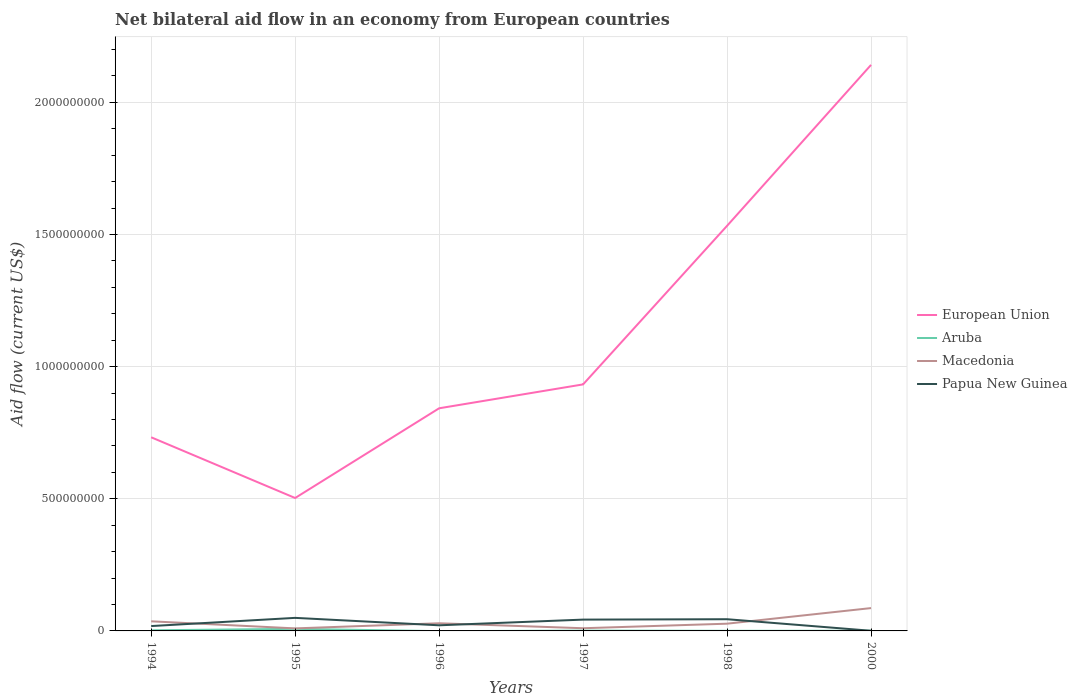How many different coloured lines are there?
Your response must be concise. 4. Does the line corresponding to Aruba intersect with the line corresponding to Papua New Guinea?
Your answer should be compact. Yes. Across all years, what is the maximum net bilateral aid flow in European Union?
Your answer should be compact. 5.03e+08. What is the total net bilateral aid flow in Macedonia in the graph?
Provide a short and direct response. -5.00e+07. What is the difference between the highest and the second highest net bilateral aid flow in Papua New Guinea?
Keep it short and to the point. 4.88e+07. What is the difference between the highest and the lowest net bilateral aid flow in European Union?
Provide a succinct answer. 2. How many lines are there?
Keep it short and to the point. 4. How many years are there in the graph?
Your answer should be compact. 6. What is the difference between two consecutive major ticks on the Y-axis?
Ensure brevity in your answer.  5.00e+08. Are the values on the major ticks of Y-axis written in scientific E-notation?
Your answer should be compact. No. Does the graph contain any zero values?
Provide a succinct answer. Yes. Does the graph contain grids?
Offer a terse response. Yes. Where does the legend appear in the graph?
Make the answer very short. Center right. What is the title of the graph?
Keep it short and to the point. Net bilateral aid flow in an economy from European countries. Does "South Asia" appear as one of the legend labels in the graph?
Your response must be concise. No. What is the label or title of the X-axis?
Make the answer very short. Years. What is the Aid flow (current US$) in European Union in 1994?
Your response must be concise. 7.33e+08. What is the Aid flow (current US$) of Aruba in 1994?
Keep it short and to the point. 2.36e+06. What is the Aid flow (current US$) in Macedonia in 1994?
Your answer should be compact. 3.64e+07. What is the Aid flow (current US$) of Papua New Guinea in 1994?
Your answer should be compact. 1.84e+07. What is the Aid flow (current US$) of European Union in 1995?
Ensure brevity in your answer.  5.03e+08. What is the Aid flow (current US$) in Aruba in 1995?
Provide a succinct answer. 7.86e+06. What is the Aid flow (current US$) of Macedonia in 1995?
Offer a terse response. 9.60e+06. What is the Aid flow (current US$) of Papua New Guinea in 1995?
Offer a terse response. 4.94e+07. What is the Aid flow (current US$) of European Union in 1996?
Your answer should be very brief. 8.42e+08. What is the Aid flow (current US$) of Aruba in 1996?
Your answer should be compact. 0. What is the Aid flow (current US$) of Macedonia in 1996?
Make the answer very short. 2.90e+07. What is the Aid flow (current US$) in Papua New Guinea in 1996?
Keep it short and to the point. 2.13e+07. What is the Aid flow (current US$) of European Union in 1997?
Provide a short and direct response. 9.33e+08. What is the Aid flow (current US$) of Aruba in 1997?
Your response must be concise. 1.24e+06. What is the Aid flow (current US$) in Macedonia in 1997?
Your answer should be compact. 1.02e+07. What is the Aid flow (current US$) of Papua New Guinea in 1997?
Ensure brevity in your answer.  4.28e+07. What is the Aid flow (current US$) in European Union in 1998?
Make the answer very short. 1.53e+09. What is the Aid flow (current US$) of Aruba in 1998?
Give a very brief answer. 4.10e+05. What is the Aid flow (current US$) of Macedonia in 1998?
Provide a succinct answer. 2.74e+07. What is the Aid flow (current US$) of Papua New Guinea in 1998?
Your response must be concise. 4.43e+07. What is the Aid flow (current US$) of European Union in 2000?
Your response must be concise. 2.14e+09. What is the Aid flow (current US$) in Aruba in 2000?
Provide a succinct answer. 6.90e+05. What is the Aid flow (current US$) of Macedonia in 2000?
Your answer should be compact. 8.64e+07. What is the Aid flow (current US$) in Papua New Guinea in 2000?
Provide a succinct answer. 5.70e+05. Across all years, what is the maximum Aid flow (current US$) of European Union?
Your answer should be compact. 2.14e+09. Across all years, what is the maximum Aid flow (current US$) in Aruba?
Keep it short and to the point. 7.86e+06. Across all years, what is the maximum Aid flow (current US$) of Macedonia?
Offer a terse response. 8.64e+07. Across all years, what is the maximum Aid flow (current US$) in Papua New Guinea?
Give a very brief answer. 4.94e+07. Across all years, what is the minimum Aid flow (current US$) in European Union?
Ensure brevity in your answer.  5.03e+08. Across all years, what is the minimum Aid flow (current US$) in Macedonia?
Ensure brevity in your answer.  9.60e+06. Across all years, what is the minimum Aid flow (current US$) of Papua New Guinea?
Your answer should be compact. 5.70e+05. What is the total Aid flow (current US$) in European Union in the graph?
Offer a very short reply. 6.68e+09. What is the total Aid flow (current US$) of Aruba in the graph?
Keep it short and to the point. 1.26e+07. What is the total Aid flow (current US$) of Macedonia in the graph?
Ensure brevity in your answer.  1.99e+08. What is the total Aid flow (current US$) in Papua New Guinea in the graph?
Your response must be concise. 1.77e+08. What is the difference between the Aid flow (current US$) of European Union in 1994 and that in 1995?
Provide a short and direct response. 2.30e+08. What is the difference between the Aid flow (current US$) of Aruba in 1994 and that in 1995?
Offer a very short reply. -5.50e+06. What is the difference between the Aid flow (current US$) of Macedonia in 1994 and that in 1995?
Make the answer very short. 2.68e+07. What is the difference between the Aid flow (current US$) of Papua New Guinea in 1994 and that in 1995?
Provide a succinct answer. -3.10e+07. What is the difference between the Aid flow (current US$) in European Union in 1994 and that in 1996?
Keep it short and to the point. -1.10e+08. What is the difference between the Aid flow (current US$) of Macedonia in 1994 and that in 1996?
Give a very brief answer. 7.38e+06. What is the difference between the Aid flow (current US$) in Papua New Guinea in 1994 and that in 1996?
Provide a short and direct response. -2.87e+06. What is the difference between the Aid flow (current US$) in European Union in 1994 and that in 1997?
Offer a terse response. -2.00e+08. What is the difference between the Aid flow (current US$) in Aruba in 1994 and that in 1997?
Provide a succinct answer. 1.12e+06. What is the difference between the Aid flow (current US$) of Macedonia in 1994 and that in 1997?
Offer a very short reply. 2.62e+07. What is the difference between the Aid flow (current US$) of Papua New Guinea in 1994 and that in 1997?
Your response must be concise. -2.44e+07. What is the difference between the Aid flow (current US$) of European Union in 1994 and that in 1998?
Your response must be concise. -8.00e+08. What is the difference between the Aid flow (current US$) in Aruba in 1994 and that in 1998?
Make the answer very short. 1.95e+06. What is the difference between the Aid flow (current US$) of Macedonia in 1994 and that in 1998?
Keep it short and to the point. 8.99e+06. What is the difference between the Aid flow (current US$) in Papua New Guinea in 1994 and that in 1998?
Offer a terse response. -2.59e+07. What is the difference between the Aid flow (current US$) in European Union in 1994 and that in 2000?
Your response must be concise. -1.41e+09. What is the difference between the Aid flow (current US$) in Aruba in 1994 and that in 2000?
Provide a succinct answer. 1.67e+06. What is the difference between the Aid flow (current US$) in Macedonia in 1994 and that in 2000?
Offer a very short reply. -5.00e+07. What is the difference between the Aid flow (current US$) in Papua New Guinea in 1994 and that in 2000?
Give a very brief answer. 1.78e+07. What is the difference between the Aid flow (current US$) of European Union in 1995 and that in 1996?
Your response must be concise. -3.39e+08. What is the difference between the Aid flow (current US$) of Macedonia in 1995 and that in 1996?
Make the answer very short. -1.94e+07. What is the difference between the Aid flow (current US$) of Papua New Guinea in 1995 and that in 1996?
Your answer should be very brief. 2.81e+07. What is the difference between the Aid flow (current US$) in European Union in 1995 and that in 1997?
Your response must be concise. -4.30e+08. What is the difference between the Aid flow (current US$) of Aruba in 1995 and that in 1997?
Offer a terse response. 6.62e+06. What is the difference between the Aid flow (current US$) of Macedonia in 1995 and that in 1997?
Offer a terse response. -5.70e+05. What is the difference between the Aid flow (current US$) of Papua New Guinea in 1995 and that in 1997?
Offer a terse response. 6.59e+06. What is the difference between the Aid flow (current US$) of European Union in 1995 and that in 1998?
Offer a very short reply. -1.03e+09. What is the difference between the Aid flow (current US$) in Aruba in 1995 and that in 1998?
Provide a succinct answer. 7.45e+06. What is the difference between the Aid flow (current US$) of Macedonia in 1995 and that in 1998?
Give a very brief answer. -1.78e+07. What is the difference between the Aid flow (current US$) of Papua New Guinea in 1995 and that in 1998?
Your answer should be very brief. 5.12e+06. What is the difference between the Aid flow (current US$) of European Union in 1995 and that in 2000?
Your answer should be very brief. -1.64e+09. What is the difference between the Aid flow (current US$) in Aruba in 1995 and that in 2000?
Ensure brevity in your answer.  7.17e+06. What is the difference between the Aid flow (current US$) of Macedonia in 1995 and that in 2000?
Provide a short and direct response. -7.68e+07. What is the difference between the Aid flow (current US$) of Papua New Guinea in 1995 and that in 2000?
Your response must be concise. 4.88e+07. What is the difference between the Aid flow (current US$) of European Union in 1996 and that in 1997?
Offer a terse response. -9.04e+07. What is the difference between the Aid flow (current US$) of Macedonia in 1996 and that in 1997?
Your answer should be very brief. 1.88e+07. What is the difference between the Aid flow (current US$) in Papua New Guinea in 1996 and that in 1997?
Your answer should be compact. -2.15e+07. What is the difference between the Aid flow (current US$) of European Union in 1996 and that in 1998?
Your answer should be compact. -6.90e+08. What is the difference between the Aid flow (current US$) in Macedonia in 1996 and that in 1998?
Give a very brief answer. 1.61e+06. What is the difference between the Aid flow (current US$) in Papua New Guinea in 1996 and that in 1998?
Provide a short and direct response. -2.30e+07. What is the difference between the Aid flow (current US$) of European Union in 1996 and that in 2000?
Provide a succinct answer. -1.30e+09. What is the difference between the Aid flow (current US$) of Macedonia in 1996 and that in 2000?
Ensure brevity in your answer.  -5.74e+07. What is the difference between the Aid flow (current US$) of Papua New Guinea in 1996 and that in 2000?
Your answer should be compact. 2.07e+07. What is the difference between the Aid flow (current US$) in European Union in 1997 and that in 1998?
Your answer should be very brief. -6.00e+08. What is the difference between the Aid flow (current US$) in Aruba in 1997 and that in 1998?
Your response must be concise. 8.30e+05. What is the difference between the Aid flow (current US$) of Macedonia in 1997 and that in 1998?
Provide a succinct answer. -1.72e+07. What is the difference between the Aid flow (current US$) of Papua New Guinea in 1997 and that in 1998?
Your answer should be compact. -1.47e+06. What is the difference between the Aid flow (current US$) of European Union in 1997 and that in 2000?
Provide a succinct answer. -1.21e+09. What is the difference between the Aid flow (current US$) in Macedonia in 1997 and that in 2000?
Ensure brevity in your answer.  -7.62e+07. What is the difference between the Aid flow (current US$) in Papua New Guinea in 1997 and that in 2000?
Offer a terse response. 4.22e+07. What is the difference between the Aid flow (current US$) of European Union in 1998 and that in 2000?
Your answer should be very brief. -6.09e+08. What is the difference between the Aid flow (current US$) in Aruba in 1998 and that in 2000?
Provide a succinct answer. -2.80e+05. What is the difference between the Aid flow (current US$) in Macedonia in 1998 and that in 2000?
Your response must be concise. -5.90e+07. What is the difference between the Aid flow (current US$) in Papua New Guinea in 1998 and that in 2000?
Provide a short and direct response. 4.37e+07. What is the difference between the Aid flow (current US$) in European Union in 1994 and the Aid flow (current US$) in Aruba in 1995?
Give a very brief answer. 7.25e+08. What is the difference between the Aid flow (current US$) in European Union in 1994 and the Aid flow (current US$) in Macedonia in 1995?
Keep it short and to the point. 7.23e+08. What is the difference between the Aid flow (current US$) in European Union in 1994 and the Aid flow (current US$) in Papua New Guinea in 1995?
Offer a very short reply. 6.83e+08. What is the difference between the Aid flow (current US$) in Aruba in 1994 and the Aid flow (current US$) in Macedonia in 1995?
Provide a succinct answer. -7.24e+06. What is the difference between the Aid flow (current US$) in Aruba in 1994 and the Aid flow (current US$) in Papua New Guinea in 1995?
Give a very brief answer. -4.70e+07. What is the difference between the Aid flow (current US$) of Macedonia in 1994 and the Aid flow (current US$) of Papua New Guinea in 1995?
Provide a succinct answer. -1.30e+07. What is the difference between the Aid flow (current US$) in European Union in 1994 and the Aid flow (current US$) in Macedonia in 1996?
Your answer should be compact. 7.04e+08. What is the difference between the Aid flow (current US$) of European Union in 1994 and the Aid flow (current US$) of Papua New Guinea in 1996?
Offer a terse response. 7.11e+08. What is the difference between the Aid flow (current US$) of Aruba in 1994 and the Aid flow (current US$) of Macedonia in 1996?
Your answer should be very brief. -2.66e+07. What is the difference between the Aid flow (current US$) of Aruba in 1994 and the Aid flow (current US$) of Papua New Guinea in 1996?
Ensure brevity in your answer.  -1.89e+07. What is the difference between the Aid flow (current US$) in Macedonia in 1994 and the Aid flow (current US$) in Papua New Guinea in 1996?
Your response must be concise. 1.51e+07. What is the difference between the Aid flow (current US$) in European Union in 1994 and the Aid flow (current US$) in Aruba in 1997?
Make the answer very short. 7.31e+08. What is the difference between the Aid flow (current US$) in European Union in 1994 and the Aid flow (current US$) in Macedonia in 1997?
Offer a very short reply. 7.22e+08. What is the difference between the Aid flow (current US$) of European Union in 1994 and the Aid flow (current US$) of Papua New Guinea in 1997?
Your response must be concise. 6.90e+08. What is the difference between the Aid flow (current US$) of Aruba in 1994 and the Aid flow (current US$) of Macedonia in 1997?
Keep it short and to the point. -7.81e+06. What is the difference between the Aid flow (current US$) in Aruba in 1994 and the Aid flow (current US$) in Papua New Guinea in 1997?
Make the answer very short. -4.04e+07. What is the difference between the Aid flow (current US$) in Macedonia in 1994 and the Aid flow (current US$) in Papua New Guinea in 1997?
Ensure brevity in your answer.  -6.43e+06. What is the difference between the Aid flow (current US$) of European Union in 1994 and the Aid flow (current US$) of Aruba in 1998?
Provide a succinct answer. 7.32e+08. What is the difference between the Aid flow (current US$) of European Union in 1994 and the Aid flow (current US$) of Macedonia in 1998?
Give a very brief answer. 7.05e+08. What is the difference between the Aid flow (current US$) of European Union in 1994 and the Aid flow (current US$) of Papua New Guinea in 1998?
Make the answer very short. 6.88e+08. What is the difference between the Aid flow (current US$) in Aruba in 1994 and the Aid flow (current US$) in Macedonia in 1998?
Offer a terse response. -2.50e+07. What is the difference between the Aid flow (current US$) of Aruba in 1994 and the Aid flow (current US$) of Papua New Guinea in 1998?
Ensure brevity in your answer.  -4.19e+07. What is the difference between the Aid flow (current US$) in Macedonia in 1994 and the Aid flow (current US$) in Papua New Guinea in 1998?
Offer a terse response. -7.90e+06. What is the difference between the Aid flow (current US$) in European Union in 1994 and the Aid flow (current US$) in Aruba in 2000?
Offer a terse response. 7.32e+08. What is the difference between the Aid flow (current US$) of European Union in 1994 and the Aid flow (current US$) of Macedonia in 2000?
Keep it short and to the point. 6.46e+08. What is the difference between the Aid flow (current US$) in European Union in 1994 and the Aid flow (current US$) in Papua New Guinea in 2000?
Offer a terse response. 7.32e+08. What is the difference between the Aid flow (current US$) in Aruba in 1994 and the Aid flow (current US$) in Macedonia in 2000?
Make the answer very short. -8.40e+07. What is the difference between the Aid flow (current US$) of Aruba in 1994 and the Aid flow (current US$) of Papua New Guinea in 2000?
Make the answer very short. 1.79e+06. What is the difference between the Aid flow (current US$) in Macedonia in 1994 and the Aid flow (current US$) in Papua New Guinea in 2000?
Make the answer very short. 3.58e+07. What is the difference between the Aid flow (current US$) of European Union in 1995 and the Aid flow (current US$) of Macedonia in 1996?
Give a very brief answer. 4.74e+08. What is the difference between the Aid flow (current US$) in European Union in 1995 and the Aid flow (current US$) in Papua New Guinea in 1996?
Provide a succinct answer. 4.82e+08. What is the difference between the Aid flow (current US$) in Aruba in 1995 and the Aid flow (current US$) in Macedonia in 1996?
Ensure brevity in your answer.  -2.11e+07. What is the difference between the Aid flow (current US$) in Aruba in 1995 and the Aid flow (current US$) in Papua New Guinea in 1996?
Keep it short and to the point. -1.34e+07. What is the difference between the Aid flow (current US$) of Macedonia in 1995 and the Aid flow (current US$) of Papua New Guinea in 1996?
Make the answer very short. -1.17e+07. What is the difference between the Aid flow (current US$) in European Union in 1995 and the Aid flow (current US$) in Aruba in 1997?
Give a very brief answer. 5.02e+08. What is the difference between the Aid flow (current US$) in European Union in 1995 and the Aid flow (current US$) in Macedonia in 1997?
Offer a very short reply. 4.93e+08. What is the difference between the Aid flow (current US$) of European Union in 1995 and the Aid flow (current US$) of Papua New Guinea in 1997?
Provide a succinct answer. 4.60e+08. What is the difference between the Aid flow (current US$) in Aruba in 1995 and the Aid flow (current US$) in Macedonia in 1997?
Keep it short and to the point. -2.31e+06. What is the difference between the Aid flow (current US$) of Aruba in 1995 and the Aid flow (current US$) of Papua New Guinea in 1997?
Your response must be concise. -3.49e+07. What is the difference between the Aid flow (current US$) in Macedonia in 1995 and the Aid flow (current US$) in Papua New Guinea in 1997?
Your answer should be compact. -3.32e+07. What is the difference between the Aid flow (current US$) of European Union in 1995 and the Aid flow (current US$) of Aruba in 1998?
Make the answer very short. 5.02e+08. What is the difference between the Aid flow (current US$) in European Union in 1995 and the Aid flow (current US$) in Macedonia in 1998?
Offer a very short reply. 4.76e+08. What is the difference between the Aid flow (current US$) of European Union in 1995 and the Aid flow (current US$) of Papua New Guinea in 1998?
Provide a succinct answer. 4.59e+08. What is the difference between the Aid flow (current US$) of Aruba in 1995 and the Aid flow (current US$) of Macedonia in 1998?
Offer a very short reply. -1.95e+07. What is the difference between the Aid flow (current US$) in Aruba in 1995 and the Aid flow (current US$) in Papua New Guinea in 1998?
Offer a terse response. -3.64e+07. What is the difference between the Aid flow (current US$) in Macedonia in 1995 and the Aid flow (current US$) in Papua New Guinea in 1998?
Provide a short and direct response. -3.47e+07. What is the difference between the Aid flow (current US$) in European Union in 1995 and the Aid flow (current US$) in Aruba in 2000?
Your response must be concise. 5.02e+08. What is the difference between the Aid flow (current US$) of European Union in 1995 and the Aid flow (current US$) of Macedonia in 2000?
Offer a terse response. 4.16e+08. What is the difference between the Aid flow (current US$) in European Union in 1995 and the Aid flow (current US$) in Papua New Guinea in 2000?
Make the answer very short. 5.02e+08. What is the difference between the Aid flow (current US$) of Aruba in 1995 and the Aid flow (current US$) of Macedonia in 2000?
Offer a very short reply. -7.85e+07. What is the difference between the Aid flow (current US$) of Aruba in 1995 and the Aid flow (current US$) of Papua New Guinea in 2000?
Give a very brief answer. 7.29e+06. What is the difference between the Aid flow (current US$) in Macedonia in 1995 and the Aid flow (current US$) in Papua New Guinea in 2000?
Provide a succinct answer. 9.03e+06. What is the difference between the Aid flow (current US$) in European Union in 1996 and the Aid flow (current US$) in Aruba in 1997?
Offer a terse response. 8.41e+08. What is the difference between the Aid flow (current US$) of European Union in 1996 and the Aid flow (current US$) of Macedonia in 1997?
Make the answer very short. 8.32e+08. What is the difference between the Aid flow (current US$) in European Union in 1996 and the Aid flow (current US$) in Papua New Guinea in 1997?
Your response must be concise. 7.99e+08. What is the difference between the Aid flow (current US$) of Macedonia in 1996 and the Aid flow (current US$) of Papua New Guinea in 1997?
Your response must be concise. -1.38e+07. What is the difference between the Aid flow (current US$) of European Union in 1996 and the Aid flow (current US$) of Aruba in 1998?
Your answer should be compact. 8.42e+08. What is the difference between the Aid flow (current US$) of European Union in 1996 and the Aid flow (current US$) of Macedonia in 1998?
Make the answer very short. 8.15e+08. What is the difference between the Aid flow (current US$) in European Union in 1996 and the Aid flow (current US$) in Papua New Guinea in 1998?
Provide a succinct answer. 7.98e+08. What is the difference between the Aid flow (current US$) in Macedonia in 1996 and the Aid flow (current US$) in Papua New Guinea in 1998?
Offer a terse response. -1.53e+07. What is the difference between the Aid flow (current US$) in European Union in 1996 and the Aid flow (current US$) in Aruba in 2000?
Keep it short and to the point. 8.42e+08. What is the difference between the Aid flow (current US$) in European Union in 1996 and the Aid flow (current US$) in Macedonia in 2000?
Offer a very short reply. 7.56e+08. What is the difference between the Aid flow (current US$) of European Union in 1996 and the Aid flow (current US$) of Papua New Guinea in 2000?
Offer a terse response. 8.42e+08. What is the difference between the Aid flow (current US$) of Macedonia in 1996 and the Aid flow (current US$) of Papua New Guinea in 2000?
Your answer should be very brief. 2.84e+07. What is the difference between the Aid flow (current US$) in European Union in 1997 and the Aid flow (current US$) in Aruba in 1998?
Keep it short and to the point. 9.32e+08. What is the difference between the Aid flow (current US$) in European Union in 1997 and the Aid flow (current US$) in Macedonia in 1998?
Offer a very short reply. 9.05e+08. What is the difference between the Aid flow (current US$) in European Union in 1997 and the Aid flow (current US$) in Papua New Guinea in 1998?
Provide a short and direct response. 8.88e+08. What is the difference between the Aid flow (current US$) in Aruba in 1997 and the Aid flow (current US$) in Macedonia in 1998?
Provide a short and direct response. -2.61e+07. What is the difference between the Aid flow (current US$) of Aruba in 1997 and the Aid flow (current US$) of Papua New Guinea in 1998?
Your answer should be compact. -4.30e+07. What is the difference between the Aid flow (current US$) of Macedonia in 1997 and the Aid flow (current US$) of Papua New Guinea in 1998?
Your answer should be compact. -3.41e+07. What is the difference between the Aid flow (current US$) of European Union in 1997 and the Aid flow (current US$) of Aruba in 2000?
Ensure brevity in your answer.  9.32e+08. What is the difference between the Aid flow (current US$) of European Union in 1997 and the Aid flow (current US$) of Macedonia in 2000?
Provide a short and direct response. 8.46e+08. What is the difference between the Aid flow (current US$) of European Union in 1997 and the Aid flow (current US$) of Papua New Guinea in 2000?
Keep it short and to the point. 9.32e+08. What is the difference between the Aid flow (current US$) in Aruba in 1997 and the Aid flow (current US$) in Macedonia in 2000?
Ensure brevity in your answer.  -8.52e+07. What is the difference between the Aid flow (current US$) of Aruba in 1997 and the Aid flow (current US$) of Papua New Guinea in 2000?
Give a very brief answer. 6.70e+05. What is the difference between the Aid flow (current US$) of Macedonia in 1997 and the Aid flow (current US$) of Papua New Guinea in 2000?
Make the answer very short. 9.60e+06. What is the difference between the Aid flow (current US$) of European Union in 1998 and the Aid flow (current US$) of Aruba in 2000?
Offer a terse response. 1.53e+09. What is the difference between the Aid flow (current US$) in European Union in 1998 and the Aid flow (current US$) in Macedonia in 2000?
Make the answer very short. 1.45e+09. What is the difference between the Aid flow (current US$) of European Union in 1998 and the Aid flow (current US$) of Papua New Guinea in 2000?
Give a very brief answer. 1.53e+09. What is the difference between the Aid flow (current US$) in Aruba in 1998 and the Aid flow (current US$) in Macedonia in 2000?
Make the answer very short. -8.60e+07. What is the difference between the Aid flow (current US$) of Aruba in 1998 and the Aid flow (current US$) of Papua New Guinea in 2000?
Offer a very short reply. -1.60e+05. What is the difference between the Aid flow (current US$) in Macedonia in 1998 and the Aid flow (current US$) in Papua New Guinea in 2000?
Give a very brief answer. 2.68e+07. What is the average Aid flow (current US$) of European Union per year?
Give a very brief answer. 1.11e+09. What is the average Aid flow (current US$) in Aruba per year?
Make the answer very short. 2.09e+06. What is the average Aid flow (current US$) of Macedonia per year?
Your answer should be very brief. 3.32e+07. What is the average Aid flow (current US$) of Papua New Guinea per year?
Offer a very short reply. 2.94e+07. In the year 1994, what is the difference between the Aid flow (current US$) of European Union and Aid flow (current US$) of Aruba?
Your answer should be compact. 7.30e+08. In the year 1994, what is the difference between the Aid flow (current US$) in European Union and Aid flow (current US$) in Macedonia?
Offer a very short reply. 6.96e+08. In the year 1994, what is the difference between the Aid flow (current US$) of European Union and Aid flow (current US$) of Papua New Guinea?
Give a very brief answer. 7.14e+08. In the year 1994, what is the difference between the Aid flow (current US$) in Aruba and Aid flow (current US$) in Macedonia?
Your response must be concise. -3.40e+07. In the year 1994, what is the difference between the Aid flow (current US$) in Aruba and Aid flow (current US$) in Papua New Guinea?
Ensure brevity in your answer.  -1.60e+07. In the year 1994, what is the difference between the Aid flow (current US$) in Macedonia and Aid flow (current US$) in Papua New Guinea?
Your answer should be very brief. 1.80e+07. In the year 1995, what is the difference between the Aid flow (current US$) of European Union and Aid flow (current US$) of Aruba?
Keep it short and to the point. 4.95e+08. In the year 1995, what is the difference between the Aid flow (current US$) in European Union and Aid flow (current US$) in Macedonia?
Offer a very short reply. 4.93e+08. In the year 1995, what is the difference between the Aid flow (current US$) in European Union and Aid flow (current US$) in Papua New Guinea?
Your answer should be very brief. 4.54e+08. In the year 1995, what is the difference between the Aid flow (current US$) in Aruba and Aid flow (current US$) in Macedonia?
Ensure brevity in your answer.  -1.74e+06. In the year 1995, what is the difference between the Aid flow (current US$) of Aruba and Aid flow (current US$) of Papua New Guinea?
Your answer should be very brief. -4.15e+07. In the year 1995, what is the difference between the Aid flow (current US$) of Macedonia and Aid flow (current US$) of Papua New Guinea?
Provide a short and direct response. -3.98e+07. In the year 1996, what is the difference between the Aid flow (current US$) in European Union and Aid flow (current US$) in Macedonia?
Keep it short and to the point. 8.13e+08. In the year 1996, what is the difference between the Aid flow (current US$) in European Union and Aid flow (current US$) in Papua New Guinea?
Provide a succinct answer. 8.21e+08. In the year 1996, what is the difference between the Aid flow (current US$) of Macedonia and Aid flow (current US$) of Papua New Guinea?
Provide a succinct answer. 7.72e+06. In the year 1997, what is the difference between the Aid flow (current US$) of European Union and Aid flow (current US$) of Aruba?
Make the answer very short. 9.31e+08. In the year 1997, what is the difference between the Aid flow (current US$) in European Union and Aid flow (current US$) in Macedonia?
Keep it short and to the point. 9.23e+08. In the year 1997, what is the difference between the Aid flow (current US$) in European Union and Aid flow (current US$) in Papua New Guinea?
Your answer should be very brief. 8.90e+08. In the year 1997, what is the difference between the Aid flow (current US$) of Aruba and Aid flow (current US$) of Macedonia?
Your answer should be compact. -8.93e+06. In the year 1997, what is the difference between the Aid flow (current US$) of Aruba and Aid flow (current US$) of Papua New Guinea?
Your answer should be compact. -4.16e+07. In the year 1997, what is the difference between the Aid flow (current US$) in Macedonia and Aid flow (current US$) in Papua New Guinea?
Ensure brevity in your answer.  -3.26e+07. In the year 1998, what is the difference between the Aid flow (current US$) in European Union and Aid flow (current US$) in Aruba?
Offer a very short reply. 1.53e+09. In the year 1998, what is the difference between the Aid flow (current US$) of European Union and Aid flow (current US$) of Macedonia?
Provide a short and direct response. 1.51e+09. In the year 1998, what is the difference between the Aid flow (current US$) in European Union and Aid flow (current US$) in Papua New Guinea?
Provide a succinct answer. 1.49e+09. In the year 1998, what is the difference between the Aid flow (current US$) in Aruba and Aid flow (current US$) in Macedonia?
Your answer should be compact. -2.70e+07. In the year 1998, what is the difference between the Aid flow (current US$) in Aruba and Aid flow (current US$) in Papua New Guinea?
Keep it short and to the point. -4.39e+07. In the year 1998, what is the difference between the Aid flow (current US$) of Macedonia and Aid flow (current US$) of Papua New Guinea?
Your response must be concise. -1.69e+07. In the year 2000, what is the difference between the Aid flow (current US$) of European Union and Aid flow (current US$) of Aruba?
Make the answer very short. 2.14e+09. In the year 2000, what is the difference between the Aid flow (current US$) in European Union and Aid flow (current US$) in Macedonia?
Make the answer very short. 2.06e+09. In the year 2000, what is the difference between the Aid flow (current US$) of European Union and Aid flow (current US$) of Papua New Guinea?
Keep it short and to the point. 2.14e+09. In the year 2000, what is the difference between the Aid flow (current US$) of Aruba and Aid flow (current US$) of Macedonia?
Ensure brevity in your answer.  -8.57e+07. In the year 2000, what is the difference between the Aid flow (current US$) of Aruba and Aid flow (current US$) of Papua New Guinea?
Ensure brevity in your answer.  1.20e+05. In the year 2000, what is the difference between the Aid flow (current US$) in Macedonia and Aid flow (current US$) in Papua New Guinea?
Provide a short and direct response. 8.58e+07. What is the ratio of the Aid flow (current US$) in European Union in 1994 to that in 1995?
Your answer should be compact. 1.46. What is the ratio of the Aid flow (current US$) in Aruba in 1994 to that in 1995?
Offer a terse response. 0.3. What is the ratio of the Aid flow (current US$) in Macedonia in 1994 to that in 1995?
Make the answer very short. 3.79. What is the ratio of the Aid flow (current US$) of Papua New Guinea in 1994 to that in 1995?
Make the answer very short. 0.37. What is the ratio of the Aid flow (current US$) in European Union in 1994 to that in 1996?
Your answer should be compact. 0.87. What is the ratio of the Aid flow (current US$) in Macedonia in 1994 to that in 1996?
Give a very brief answer. 1.25. What is the ratio of the Aid flow (current US$) of Papua New Guinea in 1994 to that in 1996?
Offer a terse response. 0.87. What is the ratio of the Aid flow (current US$) of European Union in 1994 to that in 1997?
Offer a very short reply. 0.79. What is the ratio of the Aid flow (current US$) of Aruba in 1994 to that in 1997?
Give a very brief answer. 1.9. What is the ratio of the Aid flow (current US$) of Macedonia in 1994 to that in 1997?
Ensure brevity in your answer.  3.58. What is the ratio of the Aid flow (current US$) of Papua New Guinea in 1994 to that in 1997?
Your answer should be very brief. 0.43. What is the ratio of the Aid flow (current US$) of European Union in 1994 to that in 1998?
Your answer should be very brief. 0.48. What is the ratio of the Aid flow (current US$) in Aruba in 1994 to that in 1998?
Provide a short and direct response. 5.76. What is the ratio of the Aid flow (current US$) in Macedonia in 1994 to that in 1998?
Provide a short and direct response. 1.33. What is the ratio of the Aid flow (current US$) of Papua New Guinea in 1994 to that in 1998?
Your answer should be very brief. 0.42. What is the ratio of the Aid flow (current US$) in European Union in 1994 to that in 2000?
Keep it short and to the point. 0.34. What is the ratio of the Aid flow (current US$) in Aruba in 1994 to that in 2000?
Offer a very short reply. 3.42. What is the ratio of the Aid flow (current US$) of Macedonia in 1994 to that in 2000?
Make the answer very short. 0.42. What is the ratio of the Aid flow (current US$) of Papua New Guinea in 1994 to that in 2000?
Offer a very short reply. 32.28. What is the ratio of the Aid flow (current US$) in European Union in 1995 to that in 1996?
Your answer should be compact. 0.6. What is the ratio of the Aid flow (current US$) of Macedonia in 1995 to that in 1996?
Give a very brief answer. 0.33. What is the ratio of the Aid flow (current US$) of Papua New Guinea in 1995 to that in 1996?
Ensure brevity in your answer.  2.32. What is the ratio of the Aid flow (current US$) of European Union in 1995 to that in 1997?
Give a very brief answer. 0.54. What is the ratio of the Aid flow (current US$) of Aruba in 1995 to that in 1997?
Keep it short and to the point. 6.34. What is the ratio of the Aid flow (current US$) in Macedonia in 1995 to that in 1997?
Give a very brief answer. 0.94. What is the ratio of the Aid flow (current US$) of Papua New Guinea in 1995 to that in 1997?
Your response must be concise. 1.15. What is the ratio of the Aid flow (current US$) of European Union in 1995 to that in 1998?
Provide a short and direct response. 0.33. What is the ratio of the Aid flow (current US$) of Aruba in 1995 to that in 1998?
Keep it short and to the point. 19.17. What is the ratio of the Aid flow (current US$) of Macedonia in 1995 to that in 1998?
Give a very brief answer. 0.35. What is the ratio of the Aid flow (current US$) in Papua New Guinea in 1995 to that in 1998?
Offer a terse response. 1.12. What is the ratio of the Aid flow (current US$) of European Union in 1995 to that in 2000?
Keep it short and to the point. 0.23. What is the ratio of the Aid flow (current US$) of Aruba in 1995 to that in 2000?
Provide a short and direct response. 11.39. What is the ratio of the Aid flow (current US$) in Papua New Guinea in 1995 to that in 2000?
Keep it short and to the point. 86.65. What is the ratio of the Aid flow (current US$) in European Union in 1996 to that in 1997?
Ensure brevity in your answer.  0.9. What is the ratio of the Aid flow (current US$) in Macedonia in 1996 to that in 1997?
Make the answer very short. 2.85. What is the ratio of the Aid flow (current US$) in Papua New Guinea in 1996 to that in 1997?
Give a very brief answer. 0.5. What is the ratio of the Aid flow (current US$) in European Union in 1996 to that in 1998?
Your response must be concise. 0.55. What is the ratio of the Aid flow (current US$) of Macedonia in 1996 to that in 1998?
Provide a short and direct response. 1.06. What is the ratio of the Aid flow (current US$) in Papua New Guinea in 1996 to that in 1998?
Provide a succinct answer. 0.48. What is the ratio of the Aid flow (current US$) in European Union in 1996 to that in 2000?
Your answer should be compact. 0.39. What is the ratio of the Aid flow (current US$) of Macedonia in 1996 to that in 2000?
Offer a terse response. 0.34. What is the ratio of the Aid flow (current US$) of Papua New Guinea in 1996 to that in 2000?
Ensure brevity in your answer.  37.32. What is the ratio of the Aid flow (current US$) in European Union in 1997 to that in 1998?
Your response must be concise. 0.61. What is the ratio of the Aid flow (current US$) of Aruba in 1997 to that in 1998?
Offer a very short reply. 3.02. What is the ratio of the Aid flow (current US$) of Macedonia in 1997 to that in 1998?
Give a very brief answer. 0.37. What is the ratio of the Aid flow (current US$) in Papua New Guinea in 1997 to that in 1998?
Provide a succinct answer. 0.97. What is the ratio of the Aid flow (current US$) of European Union in 1997 to that in 2000?
Your answer should be very brief. 0.44. What is the ratio of the Aid flow (current US$) in Aruba in 1997 to that in 2000?
Offer a terse response. 1.8. What is the ratio of the Aid flow (current US$) in Macedonia in 1997 to that in 2000?
Offer a terse response. 0.12. What is the ratio of the Aid flow (current US$) in Papua New Guinea in 1997 to that in 2000?
Provide a short and direct response. 75.09. What is the ratio of the Aid flow (current US$) in European Union in 1998 to that in 2000?
Your answer should be compact. 0.72. What is the ratio of the Aid flow (current US$) of Aruba in 1998 to that in 2000?
Your answer should be compact. 0.59. What is the ratio of the Aid flow (current US$) of Macedonia in 1998 to that in 2000?
Provide a succinct answer. 0.32. What is the ratio of the Aid flow (current US$) of Papua New Guinea in 1998 to that in 2000?
Your answer should be very brief. 77.67. What is the difference between the highest and the second highest Aid flow (current US$) of European Union?
Your answer should be compact. 6.09e+08. What is the difference between the highest and the second highest Aid flow (current US$) in Aruba?
Give a very brief answer. 5.50e+06. What is the difference between the highest and the second highest Aid flow (current US$) of Macedonia?
Make the answer very short. 5.00e+07. What is the difference between the highest and the second highest Aid flow (current US$) in Papua New Guinea?
Your answer should be compact. 5.12e+06. What is the difference between the highest and the lowest Aid flow (current US$) in European Union?
Make the answer very short. 1.64e+09. What is the difference between the highest and the lowest Aid flow (current US$) of Aruba?
Give a very brief answer. 7.86e+06. What is the difference between the highest and the lowest Aid flow (current US$) in Macedonia?
Provide a succinct answer. 7.68e+07. What is the difference between the highest and the lowest Aid flow (current US$) of Papua New Guinea?
Keep it short and to the point. 4.88e+07. 